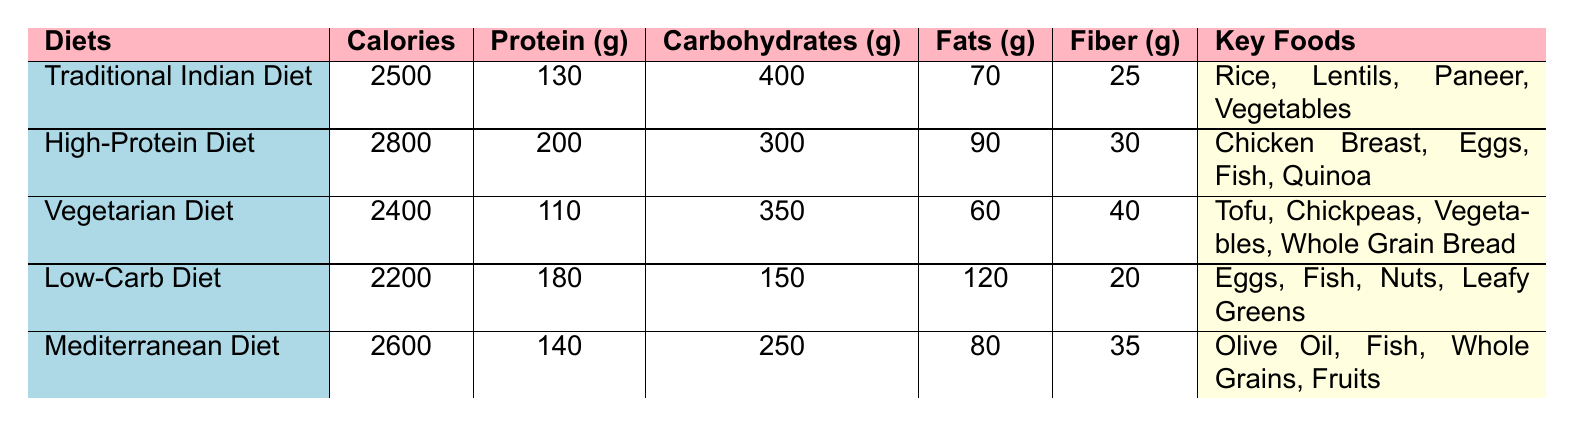What is the caloric content of the Traditional Indian Diet? The caloric content for the Traditional Indian Diet is clearly listed in the table under the "Calories" column, which shows 2500.
Answer: 2500 Which diet has the highest protein content? In the table, the "Protein (g)" column shows that the High-Protein Diet has the highest protein content of 200 grams compared to the other diets.
Answer: High-Protein Diet How many grams of carbohydrates are present in the Vegetarian Diet? Looking at the "Carbohydrates (g)" column for the Vegetarian Diet, it is recorded as 350 grams.
Answer: 350 Is the total calorie count of the Low-Carb Diet less than the Mediterranean Diet? Comparing the "Calories" column, the Low-Carb Diet has 2200 calories while the Mediterranean Diet has 2600 calories, confirming that the Low-Carb Diet is indeed less.
Answer: Yes What is the difference in fat content between the High-Protein Diet and the Low-Carb Diet? The fat content for the High-Protein Diet is 90 grams, and for the Low-Carb Diet, it is 120 grams. The difference is calculated as 120 - 90 = 30 grams.
Answer: 30 grams If you average the fiber content from the Traditional Indian Diet and the Mediterranean Diet, what do you get? The fiber content for the Traditional Indian Diet is 25 grams and for the Mediterranean Diet is 35 grams. To find the average, calculate (25 + 35) / 2 = 30 grams.
Answer: 30 grams Considering the key foods in each diet, does the Vegetarian Diet include animal products? The key foods listed for the Vegetarian Diet include Tofu, Chickpeas, Vegetables, and Whole Grain Bread, none of which are animal products, indicating it does not include them.
Answer: No Which diet has the lowest amount of fiber? The Low-Carb Diet has 20 grams of fiber, which is lower than the other diets listed in the table.
Answer: Low-Carb Diet How many grams of carbohydrates are in the combination of the Mediterranean Diet and High-Protein Diet? The Mediterranean Diet has 250 grams of carbohydrates, and the High-Protein Diet has 300 grams. Adding these together gives 250 + 300 = 550 grams of carbohydrates.
Answer: 550 grams 